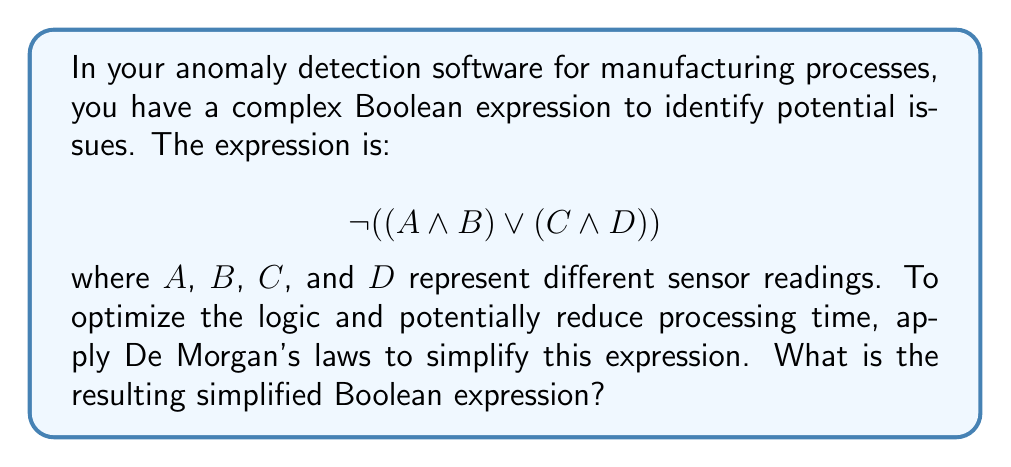Solve this math problem. Let's apply De Morgan's laws step-by-step to simplify the given expression:

1) The original expression is:
   $$ \neg ((A \land B) \lor (C \land D)) $$

2) De Morgan's first law states that the negation of a disjunction is the conjunction of the negations:
   $$ \neg (X \lor Y) \equiv (\neg X \land \neg Y) $$

3) Applying this to our expression:
   $$ (\neg (A \land B)) \land (\neg (C \land D)) $$

4) Now we can apply De Morgan's second law to each part. This law states that the negation of a conjunction is the disjunction of the negations:
   $$ \neg (X \land Y) \equiv (\neg X \lor \neg Y) $$

5) Applying this to $(A \land B)$ and $(C \land D)$:
   $$ ((\neg A \lor \neg B) \land (\neg C \lor \neg D)) $$

6) This is the final simplified expression using De Morgan's laws.
Answer: $$ ((\neg A \lor \neg B) \land (\neg C \lor \neg D)) $$ 